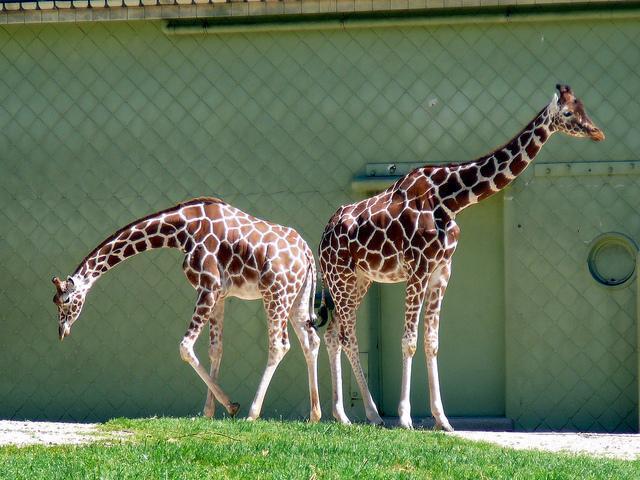How many giraffes?
Give a very brief answer. 2. How many giraffes can be seen?
Give a very brief answer. 2. How many women are there?
Give a very brief answer. 0. 